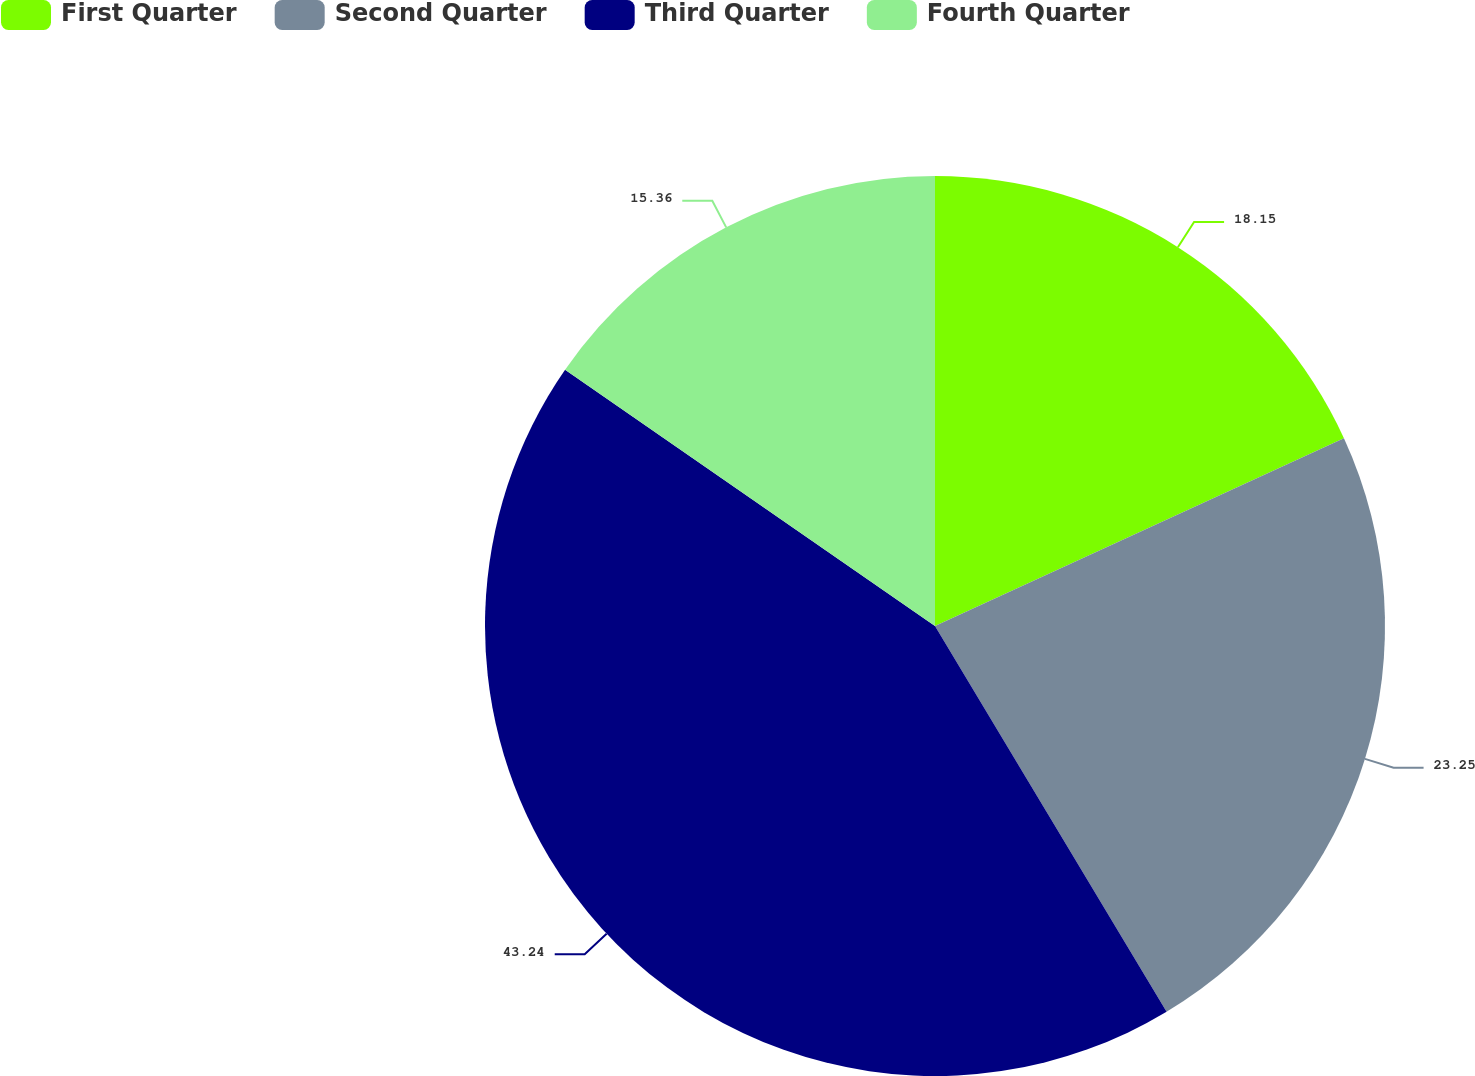Convert chart. <chart><loc_0><loc_0><loc_500><loc_500><pie_chart><fcel>First Quarter<fcel>Second Quarter<fcel>Third Quarter<fcel>Fourth Quarter<nl><fcel>18.15%<fcel>23.25%<fcel>43.25%<fcel>15.36%<nl></chart> 